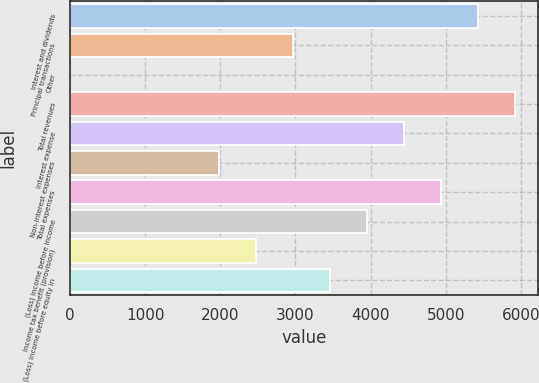<chart> <loc_0><loc_0><loc_500><loc_500><bar_chart><fcel>Interest and dividends<fcel>Principal transactions<fcel>Other<fcel>Total revenues<fcel>Interest expense<fcel>Non-interest expenses<fcel>Total expenses<fcel>(Loss) income before income<fcel>Income tax benefit (provision)<fcel>(Loss) income before equity in<nl><fcel>5432.3<fcel>2965.8<fcel>6<fcel>5925.6<fcel>4445.7<fcel>1979.2<fcel>4939<fcel>3952.4<fcel>2472.5<fcel>3459.1<nl></chart> 